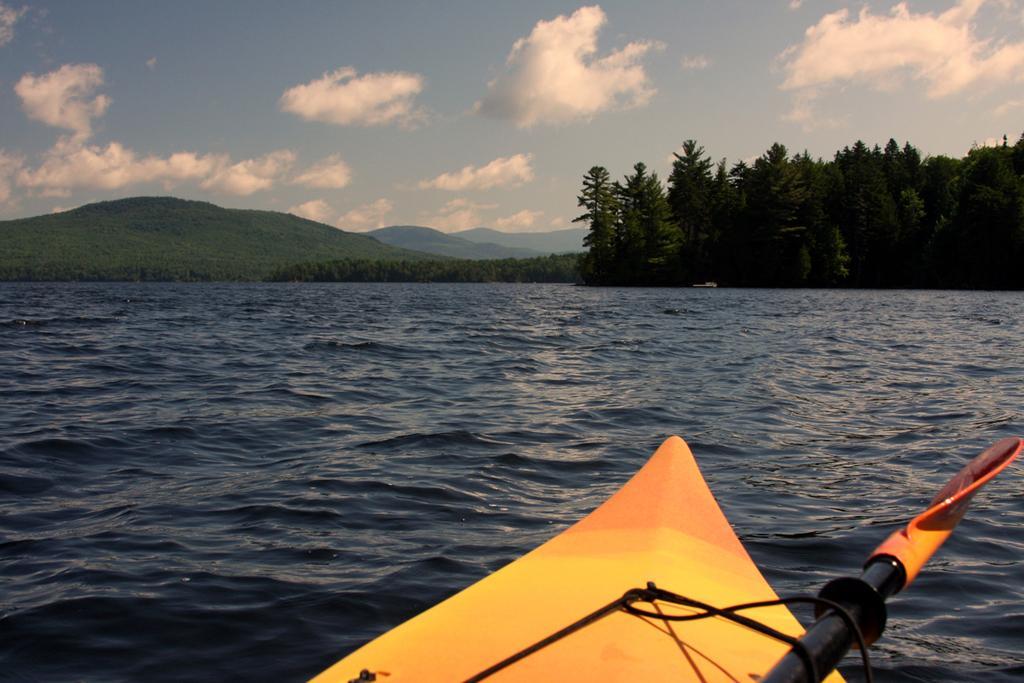Could you give a brief overview of what you see in this image? In this picture we can see the beautiful view of the river water. Behind there are some trees and mountains. In the front bottom side there is a small yellow boat. On the top there is a sky and clouds. 